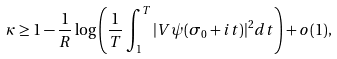Convert formula to latex. <formula><loc_0><loc_0><loc_500><loc_500>\kappa \geq 1 - \frac { 1 } { R } \log \left ( \frac { 1 } { T } \int _ { 1 } ^ { T } | V \psi ( \sigma _ { 0 } + i t ) | ^ { 2 } d t \right ) + o ( 1 ) ,</formula> 